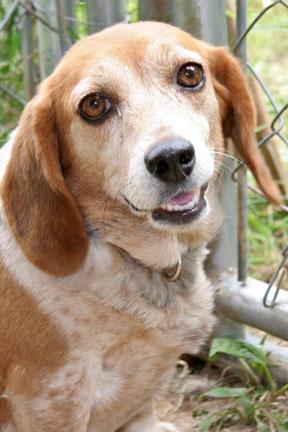Is this dog running?
Answer briefly. No. Is this dog injured?
Quick response, please. No. Does this appear to be a puppy or adult dog?
Quick response, please. Adult. 